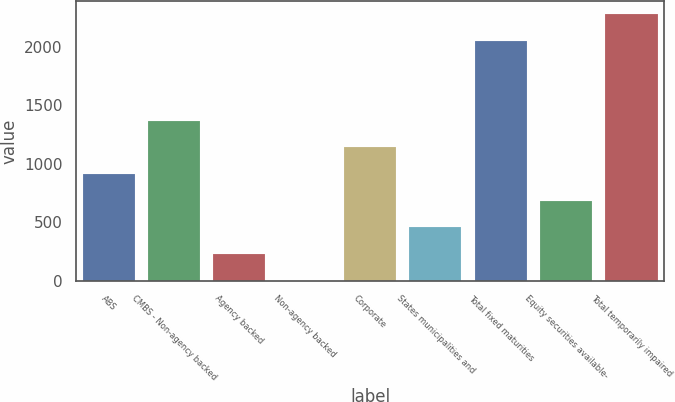<chart> <loc_0><loc_0><loc_500><loc_500><bar_chart><fcel>ABS<fcel>CMBS - Non-agency backed<fcel>Agency backed<fcel>Non-agency backed<fcel>Corporate<fcel>States municipalities and<fcel>Total fixed maturities<fcel>Equity securities available-<fcel>Total temporarily impaired<nl><fcel>913.2<fcel>1368.8<fcel>229.8<fcel>2<fcel>1141<fcel>457.6<fcel>2047<fcel>685.4<fcel>2280<nl></chart> 